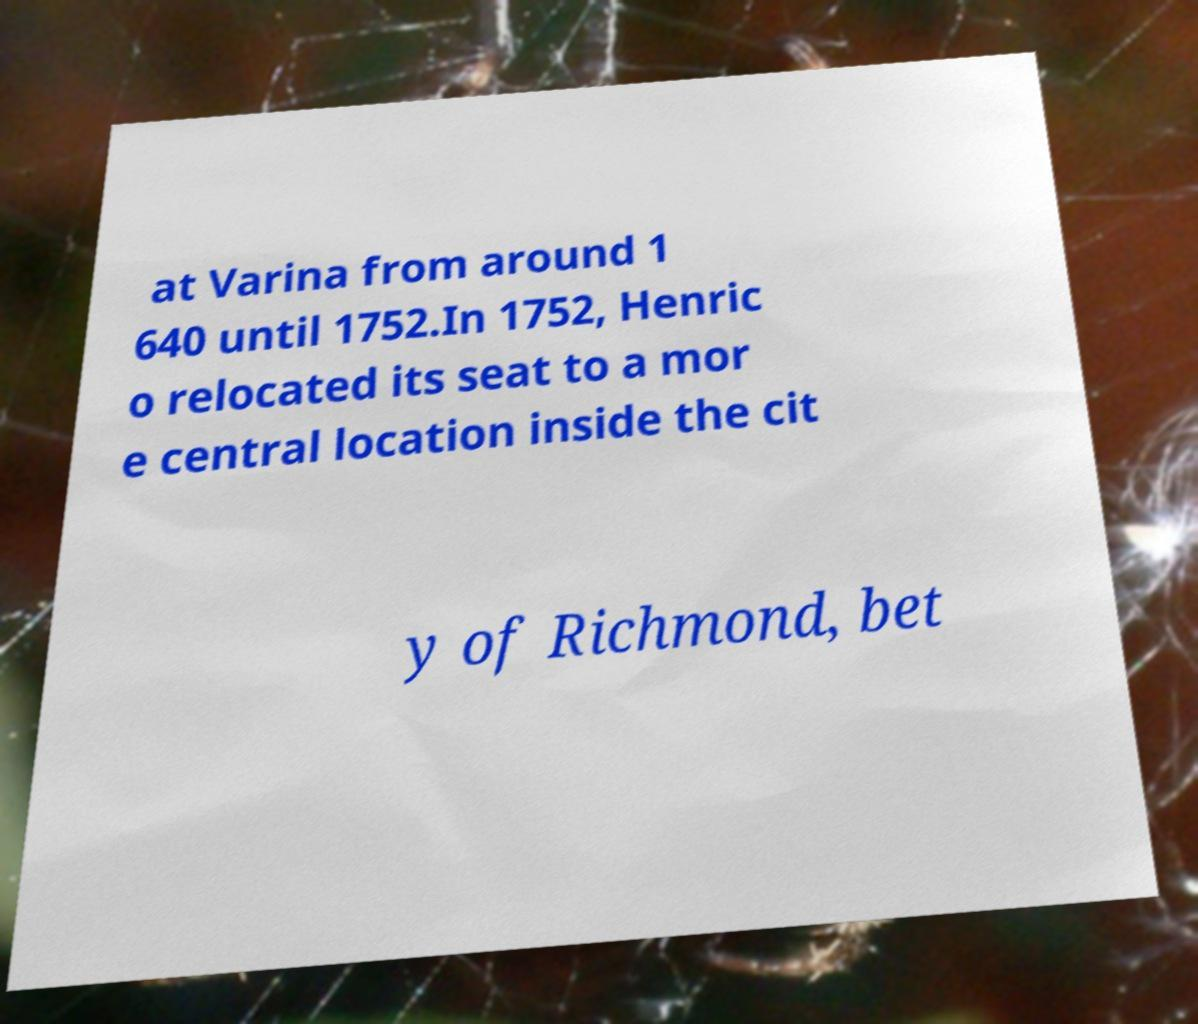Could you assist in decoding the text presented in this image and type it out clearly? at Varina from around 1 640 until 1752.In 1752, Henric o relocated its seat to a mor e central location inside the cit y of Richmond, bet 